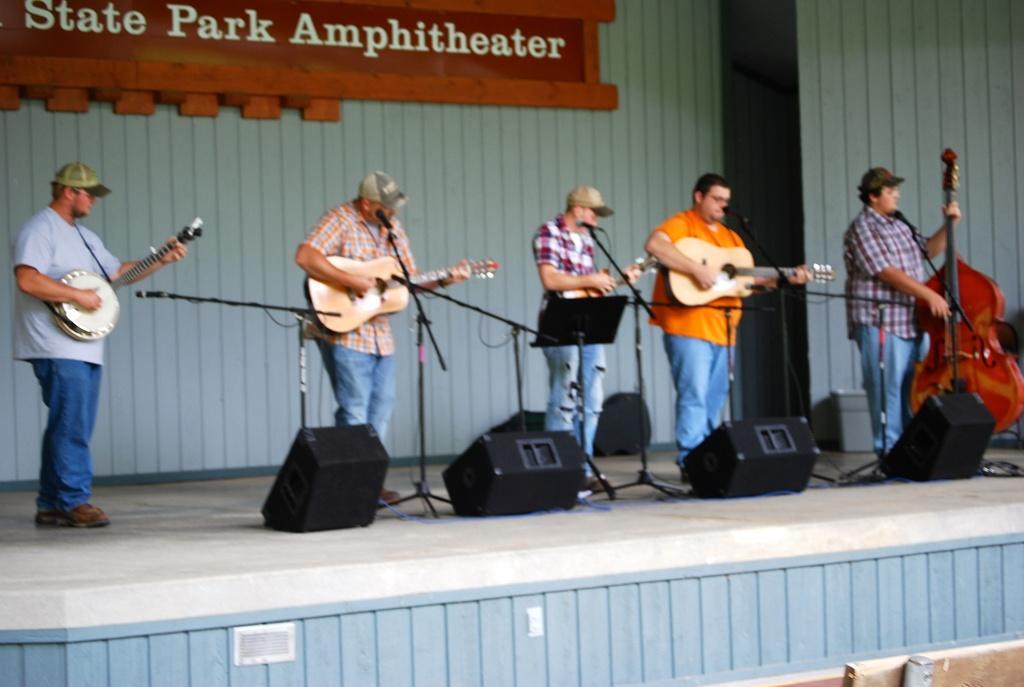How would you summarize this image in a sentence or two? In this image there are five persons standing on the stage. There are playing a musical instruments. There is a mic and a stand. On the stage there are speakers. At the background we can see a board in a brown color. 